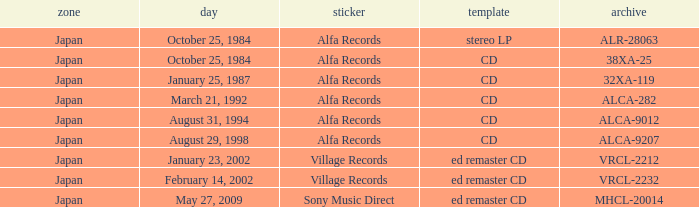What is the catalog of the release from January 23, 2002? VRCL-2212. 